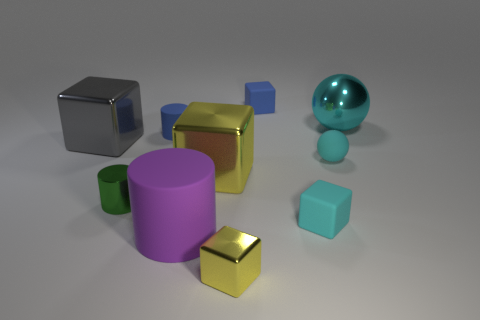Subtract all small blue matte cylinders. How many cylinders are left? 2 Subtract all blue cylinders. How many cylinders are left? 2 Subtract all cylinders. How many objects are left? 7 Subtract 4 cubes. How many cubes are left? 1 Subtract all yellow blocks. How many green cylinders are left? 1 Subtract all green balls. Subtract all green cylinders. How many objects are left? 9 Add 3 small green things. How many small green things are left? 4 Add 3 large blocks. How many large blocks exist? 5 Subtract 0 green blocks. How many objects are left? 10 Subtract all brown cylinders. Subtract all cyan balls. How many cylinders are left? 3 